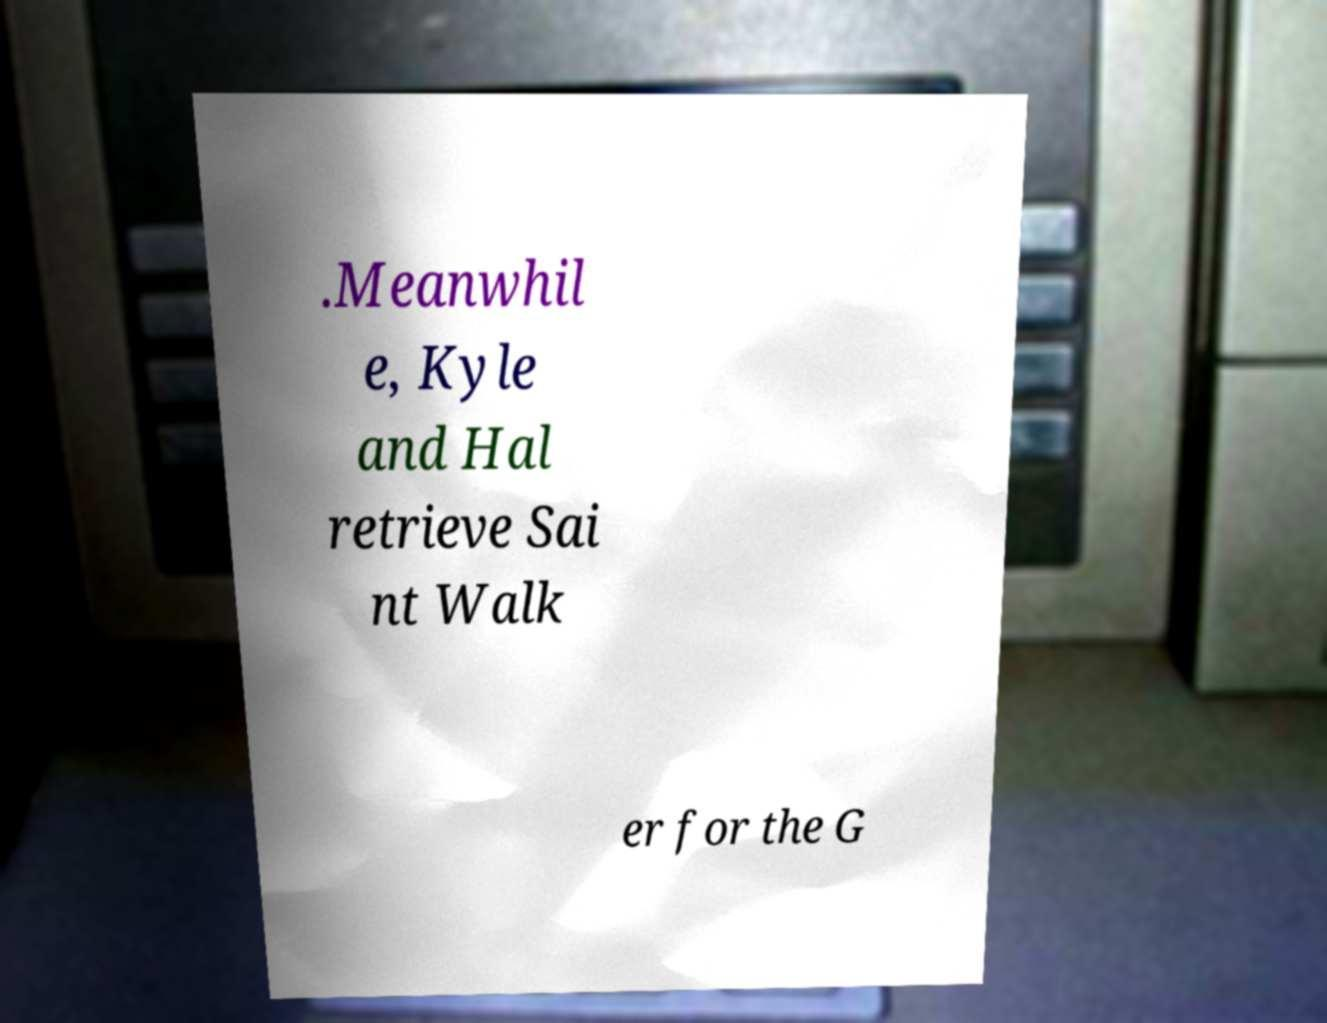Please read and relay the text visible in this image. What does it say? .Meanwhil e, Kyle and Hal retrieve Sai nt Walk er for the G 